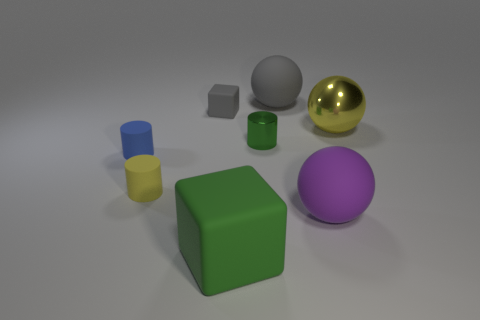What number of other things are made of the same material as the big yellow sphere?
Ensure brevity in your answer.  1. Does the yellow thing that is on the left side of the big green rubber object have the same material as the large thing that is to the left of the tiny metal thing?
Provide a succinct answer. Yes. How many large objects are both behind the big green block and to the left of the big purple ball?
Provide a short and direct response. 1. Are there any small brown matte things of the same shape as the purple matte thing?
Your response must be concise. No. The gray thing that is the same size as the blue thing is what shape?
Keep it short and to the point. Cube. Are there an equal number of gray objects that are in front of the small yellow rubber object and large green cubes that are on the right side of the tiny green shiny cylinder?
Your answer should be very brief. Yes. There is a gray rubber thing to the right of the rubber cube in front of the big metal ball; what is its size?
Offer a very short reply. Large. Is there a yellow shiny thing that has the same size as the yellow cylinder?
Your response must be concise. No. There is a big cube that is the same material as the tiny gray thing; what is its color?
Offer a terse response. Green. Is the number of small purple metallic cylinders less than the number of tiny metallic things?
Ensure brevity in your answer.  Yes. 